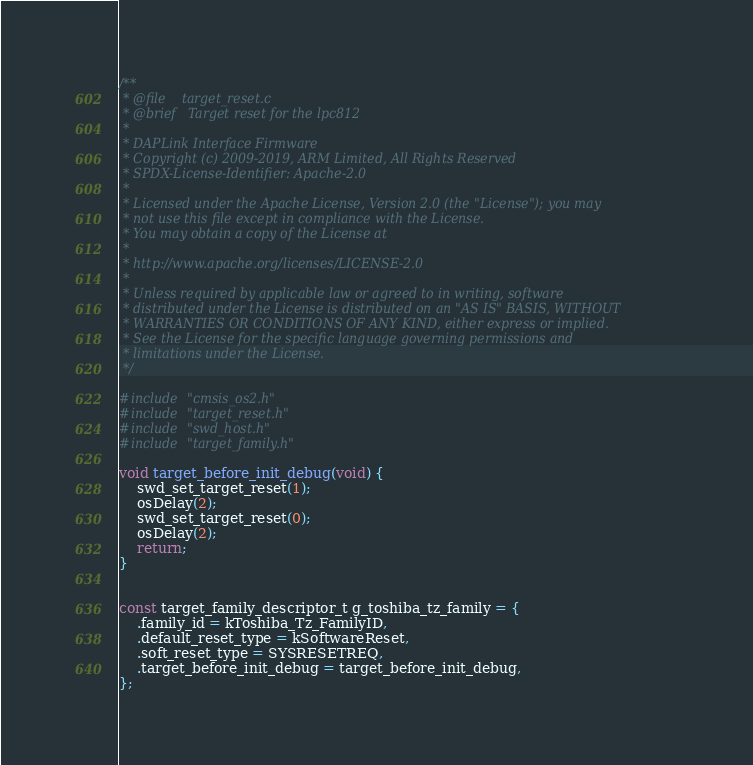Convert code to text. <code><loc_0><loc_0><loc_500><loc_500><_C_>/**
 * @file    target_reset.c
 * @brief   Target reset for the lpc812
 *
 * DAPLink Interface Firmware
 * Copyright (c) 2009-2019, ARM Limited, All Rights Reserved
 * SPDX-License-Identifier: Apache-2.0
 *
 * Licensed under the Apache License, Version 2.0 (the "License"); you may
 * not use this file except in compliance with the License.
 * You may obtain a copy of the License at
 *
 * http://www.apache.org/licenses/LICENSE-2.0
 *
 * Unless required by applicable law or agreed to in writing, software
 * distributed under the License is distributed on an "AS IS" BASIS, WITHOUT
 * WARRANTIES OR CONDITIONS OF ANY KIND, either express or implied.
 * See the License for the specific language governing permissions and
 * limitations under the License.
 */
 
#include "cmsis_os2.h"
#include "target_reset.h"
#include "swd_host.h"
#include "target_family.h"

void target_before_init_debug(void) {
    swd_set_target_reset(1);
    osDelay(2);
    swd_set_target_reset(0);
    osDelay(2);
    return;
}


const target_family_descriptor_t g_toshiba_tz_family = {
    .family_id = kToshiba_Tz_FamilyID,
    .default_reset_type = kSoftwareReset,
    .soft_reset_type = SYSRESETREQ,
    .target_before_init_debug = target_before_init_debug,
};
</code> 